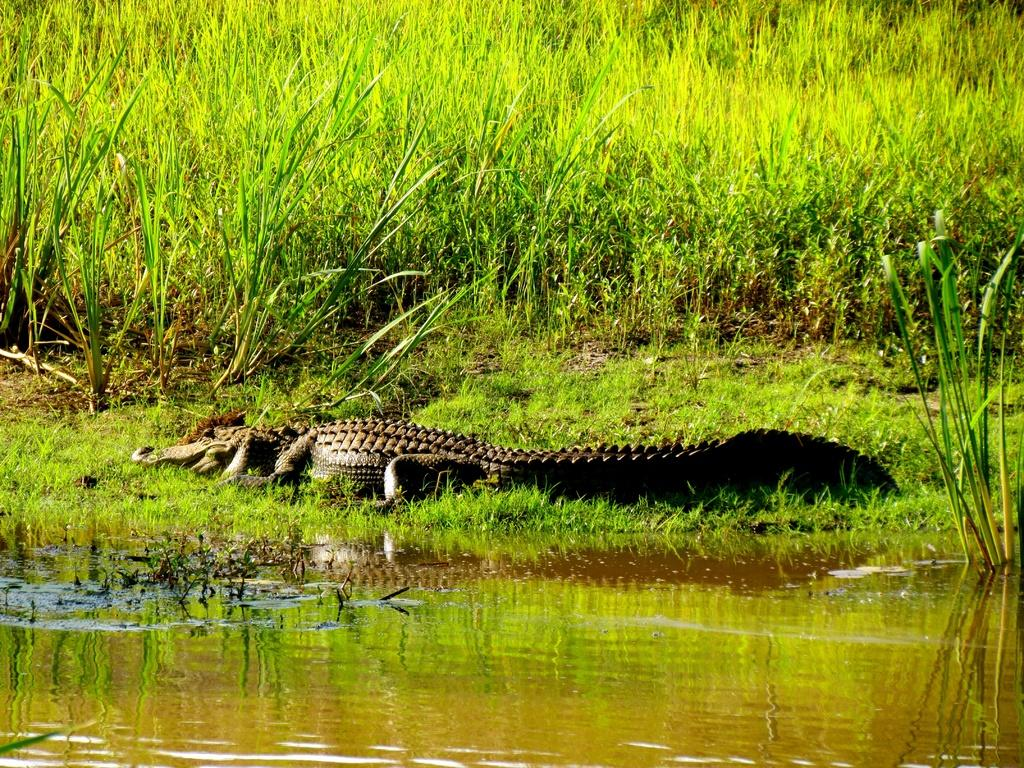What is the primary element visible in the image? There is water in the image. What type of animal can be seen in the water? There is a crocodile in the image. What type of vegetation is present in the image? Grass and plants are present in the image. What type of insurance policy is being discussed in the image? There is no discussion of insurance policies in the image; it features water, a crocodile, grass, and plants. 